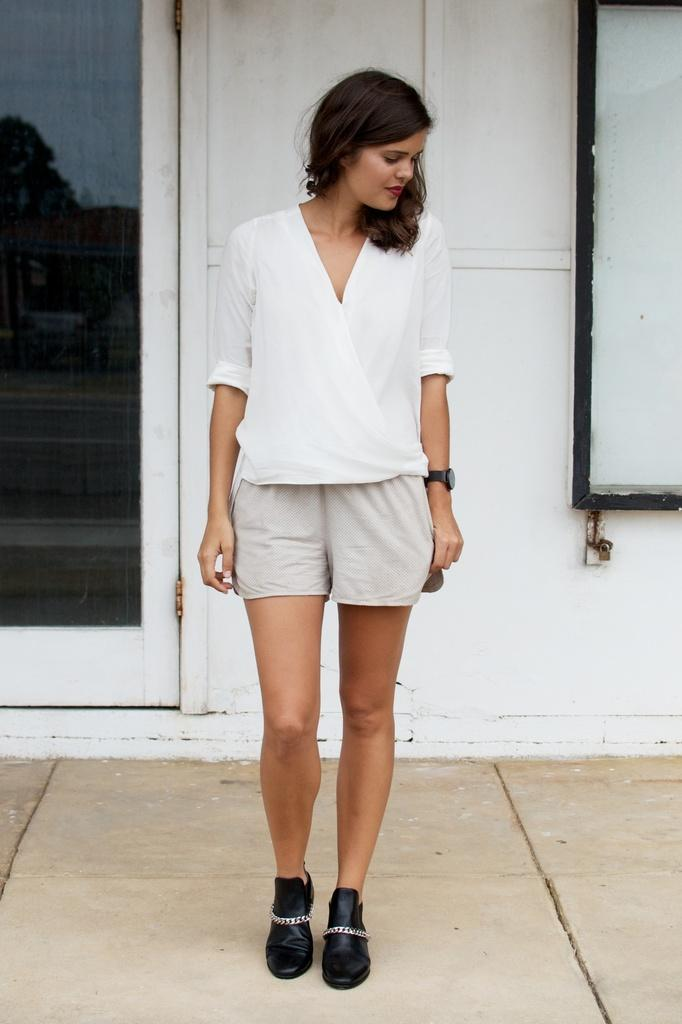Who is present in the image? There is a woman in the image. What is the woman doing in the image? The woman is standing on the floor. What is the woman wearing in the image? The woman is wearing a white dress. What can be seen in the background of the image? There is a wall and a door in the background of the image. How many cows are visible in the image? There are no cows present in the image. What type of jeans is the woman wearing in the image? The woman is not wearing jeans in the image; she is wearing a white dress. 